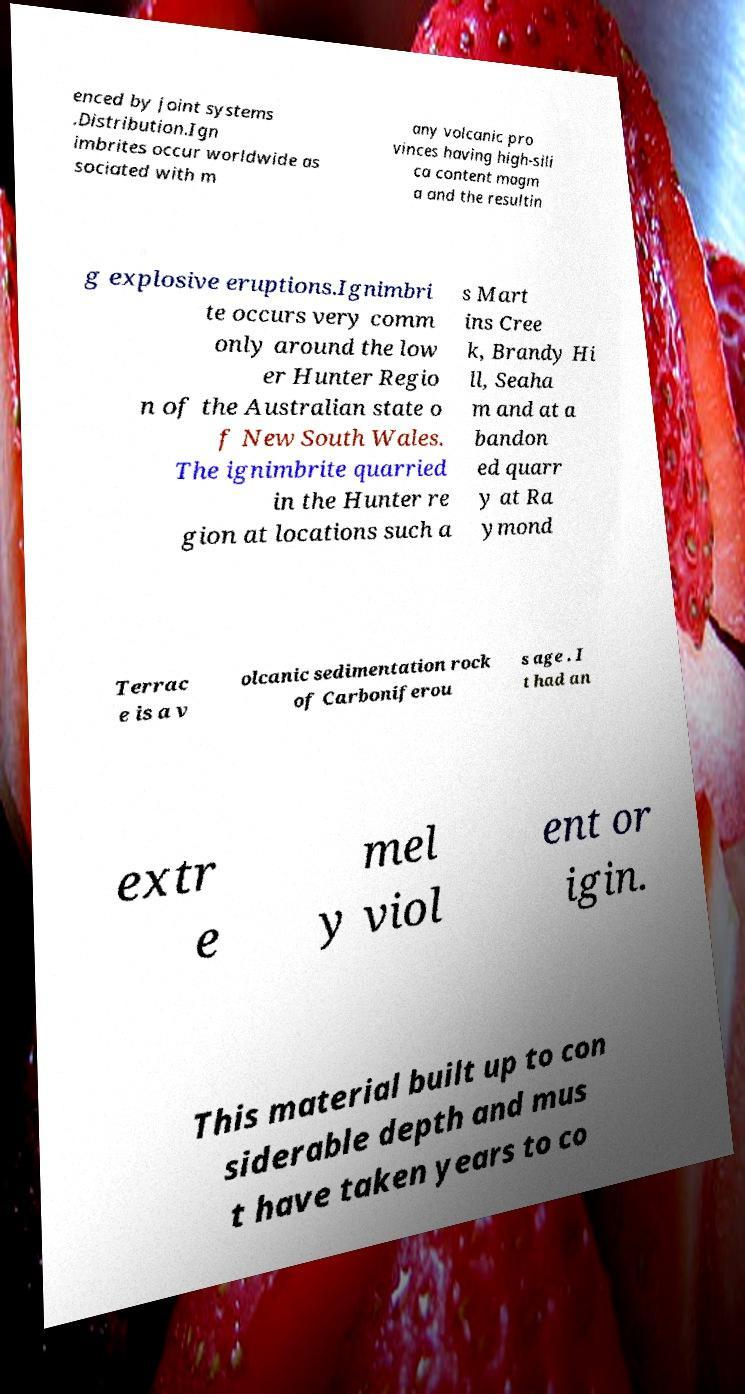Please read and relay the text visible in this image. What does it say? enced by joint systems .Distribution.Ign imbrites occur worldwide as sociated with m any volcanic pro vinces having high-sili ca content magm a and the resultin g explosive eruptions.Ignimbri te occurs very comm only around the low er Hunter Regio n of the Australian state o f New South Wales. The ignimbrite quarried in the Hunter re gion at locations such a s Mart ins Cree k, Brandy Hi ll, Seaha m and at a bandon ed quarr y at Ra ymond Terrac e is a v olcanic sedimentation rock of Carboniferou s age . I t had an extr e mel y viol ent or igin. This material built up to con siderable depth and mus t have taken years to co 